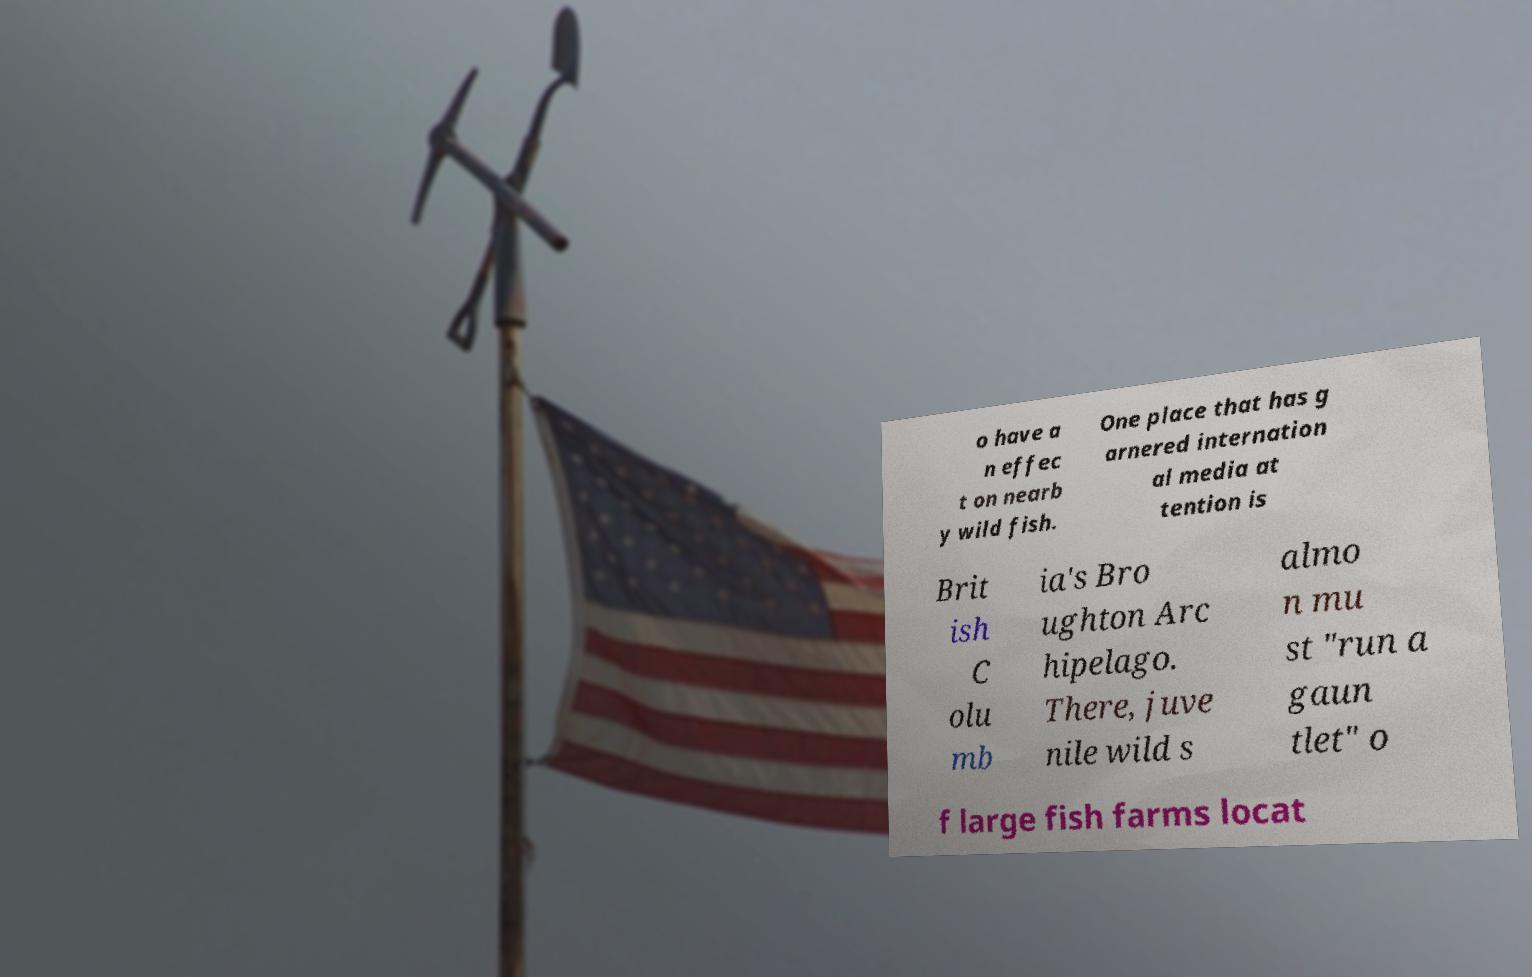For documentation purposes, I need the text within this image transcribed. Could you provide that? o have a n effec t on nearb y wild fish. One place that has g arnered internation al media at tention is Brit ish C olu mb ia's Bro ughton Arc hipelago. There, juve nile wild s almo n mu st "run a gaun tlet" o f large fish farms locat 